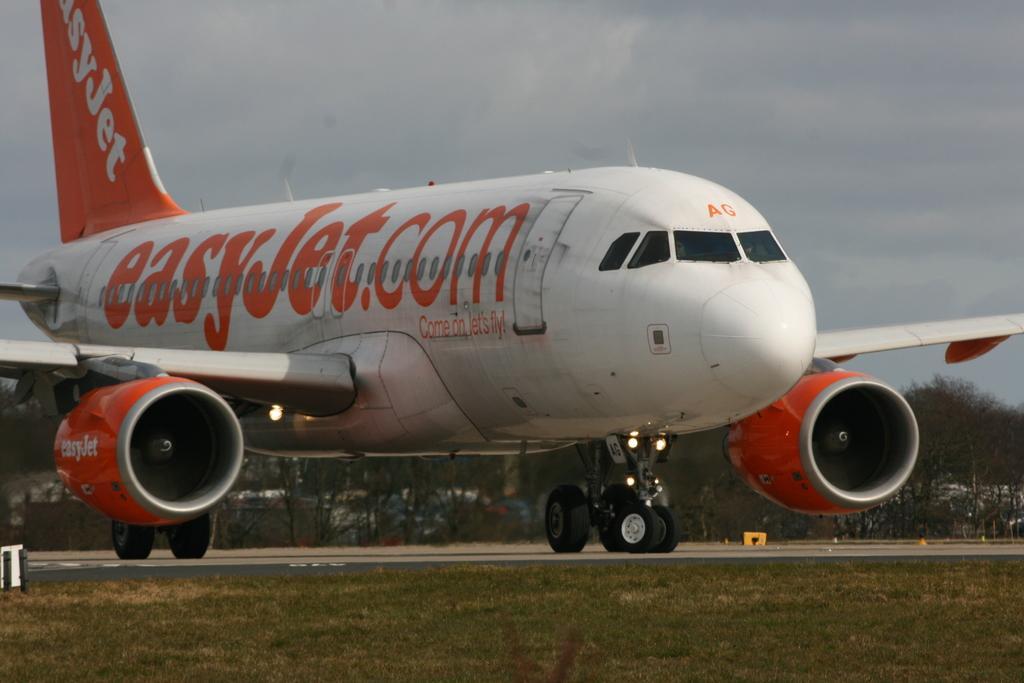In one or two sentences, can you explain what this image depicts? In this image, I can see an airplane on the runway. In the background, there are trees and the sky. At the bottom of the image, I can see the grass. 